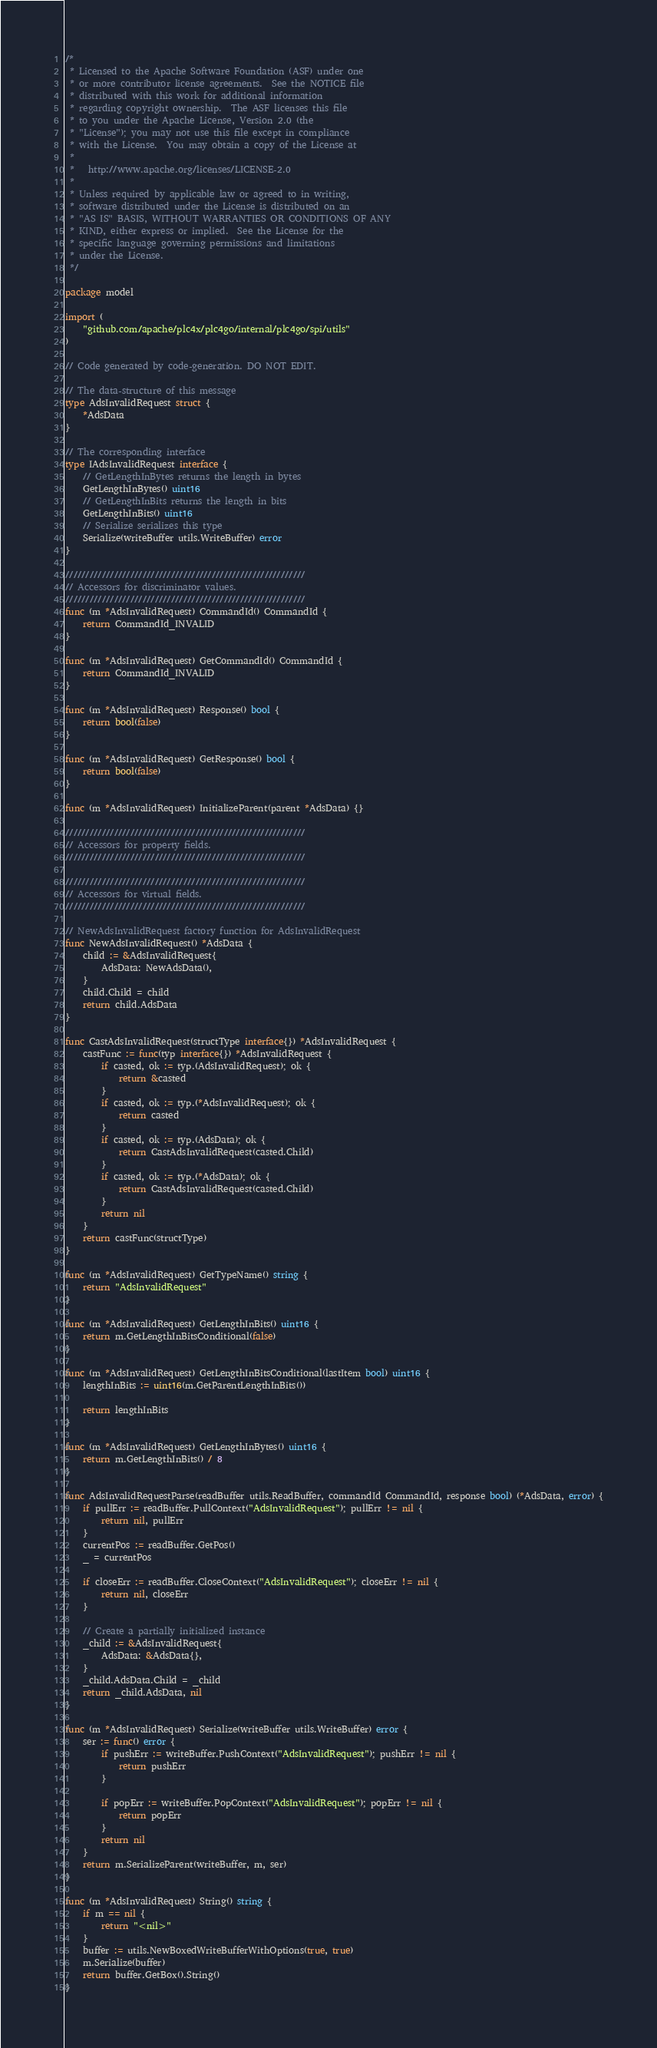<code> <loc_0><loc_0><loc_500><loc_500><_Go_>/*
 * Licensed to the Apache Software Foundation (ASF) under one
 * or more contributor license agreements.  See the NOTICE file
 * distributed with this work for additional information
 * regarding copyright ownership.  The ASF licenses this file
 * to you under the Apache License, Version 2.0 (the
 * "License"); you may not use this file except in compliance
 * with the License.  You may obtain a copy of the License at
 *
 *   http://www.apache.org/licenses/LICENSE-2.0
 *
 * Unless required by applicable law or agreed to in writing,
 * software distributed under the License is distributed on an
 * "AS IS" BASIS, WITHOUT WARRANTIES OR CONDITIONS OF ANY
 * KIND, either express or implied.  See the License for the
 * specific language governing permissions and limitations
 * under the License.
 */

package model

import (
	"github.com/apache/plc4x/plc4go/internal/plc4go/spi/utils"
)

// Code generated by code-generation. DO NOT EDIT.

// The data-structure of this message
type AdsInvalidRequest struct {
	*AdsData
}

// The corresponding interface
type IAdsInvalidRequest interface {
	// GetLengthInBytes returns the length in bytes
	GetLengthInBytes() uint16
	// GetLengthInBits returns the length in bits
	GetLengthInBits() uint16
	// Serialize serializes this type
	Serialize(writeBuffer utils.WriteBuffer) error
}

///////////////////////////////////////////////////////////
// Accessors for discriminator values.
///////////////////////////////////////////////////////////
func (m *AdsInvalidRequest) CommandId() CommandId {
	return CommandId_INVALID
}

func (m *AdsInvalidRequest) GetCommandId() CommandId {
	return CommandId_INVALID
}

func (m *AdsInvalidRequest) Response() bool {
	return bool(false)
}

func (m *AdsInvalidRequest) GetResponse() bool {
	return bool(false)
}

func (m *AdsInvalidRequest) InitializeParent(parent *AdsData) {}

///////////////////////////////////////////////////////////
// Accessors for property fields.
///////////////////////////////////////////////////////////

///////////////////////////////////////////////////////////
// Accessors for virtual fields.
///////////////////////////////////////////////////////////

// NewAdsInvalidRequest factory function for AdsInvalidRequest
func NewAdsInvalidRequest() *AdsData {
	child := &AdsInvalidRequest{
		AdsData: NewAdsData(),
	}
	child.Child = child
	return child.AdsData
}

func CastAdsInvalidRequest(structType interface{}) *AdsInvalidRequest {
	castFunc := func(typ interface{}) *AdsInvalidRequest {
		if casted, ok := typ.(AdsInvalidRequest); ok {
			return &casted
		}
		if casted, ok := typ.(*AdsInvalidRequest); ok {
			return casted
		}
		if casted, ok := typ.(AdsData); ok {
			return CastAdsInvalidRequest(casted.Child)
		}
		if casted, ok := typ.(*AdsData); ok {
			return CastAdsInvalidRequest(casted.Child)
		}
		return nil
	}
	return castFunc(structType)
}

func (m *AdsInvalidRequest) GetTypeName() string {
	return "AdsInvalidRequest"
}

func (m *AdsInvalidRequest) GetLengthInBits() uint16 {
	return m.GetLengthInBitsConditional(false)
}

func (m *AdsInvalidRequest) GetLengthInBitsConditional(lastItem bool) uint16 {
	lengthInBits := uint16(m.GetParentLengthInBits())

	return lengthInBits
}

func (m *AdsInvalidRequest) GetLengthInBytes() uint16 {
	return m.GetLengthInBits() / 8
}

func AdsInvalidRequestParse(readBuffer utils.ReadBuffer, commandId CommandId, response bool) (*AdsData, error) {
	if pullErr := readBuffer.PullContext("AdsInvalidRequest"); pullErr != nil {
		return nil, pullErr
	}
	currentPos := readBuffer.GetPos()
	_ = currentPos

	if closeErr := readBuffer.CloseContext("AdsInvalidRequest"); closeErr != nil {
		return nil, closeErr
	}

	// Create a partially initialized instance
	_child := &AdsInvalidRequest{
		AdsData: &AdsData{},
	}
	_child.AdsData.Child = _child
	return _child.AdsData, nil
}

func (m *AdsInvalidRequest) Serialize(writeBuffer utils.WriteBuffer) error {
	ser := func() error {
		if pushErr := writeBuffer.PushContext("AdsInvalidRequest"); pushErr != nil {
			return pushErr
		}

		if popErr := writeBuffer.PopContext("AdsInvalidRequest"); popErr != nil {
			return popErr
		}
		return nil
	}
	return m.SerializeParent(writeBuffer, m, ser)
}

func (m *AdsInvalidRequest) String() string {
	if m == nil {
		return "<nil>"
	}
	buffer := utils.NewBoxedWriteBufferWithOptions(true, true)
	m.Serialize(buffer)
	return buffer.GetBox().String()
}
</code> 